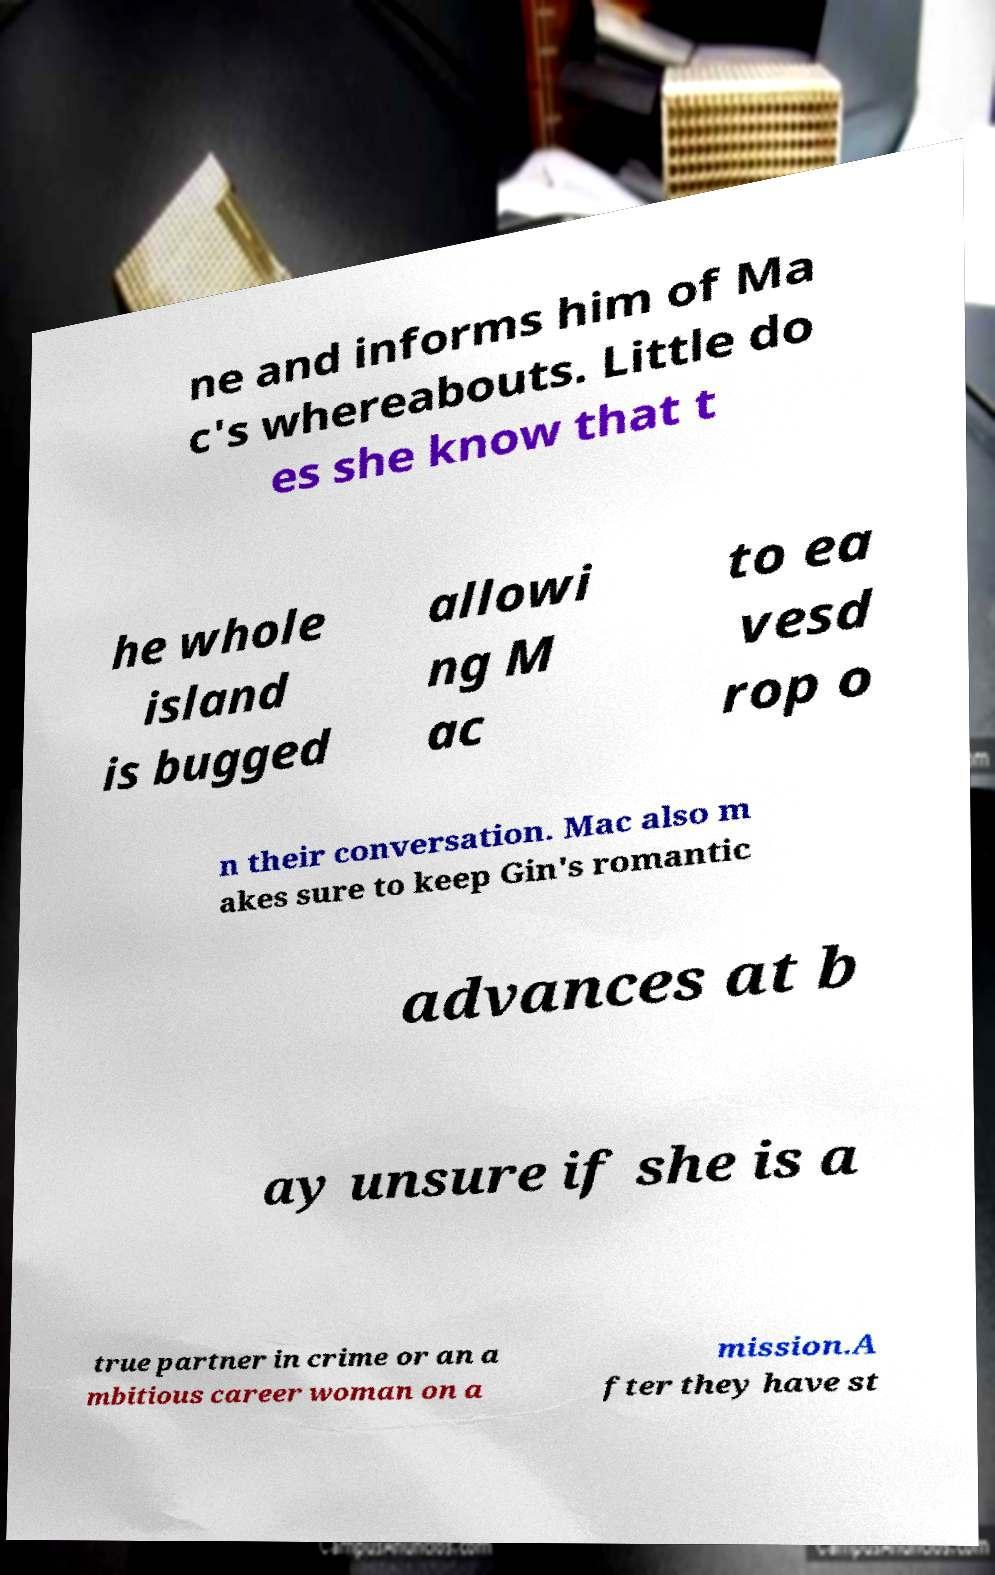Can you accurately transcribe the text from the provided image for me? ne and informs him of Ma c's whereabouts. Little do es she know that t he whole island is bugged allowi ng M ac to ea vesd rop o n their conversation. Mac also m akes sure to keep Gin's romantic advances at b ay unsure if she is a true partner in crime or an a mbitious career woman on a mission.A fter they have st 